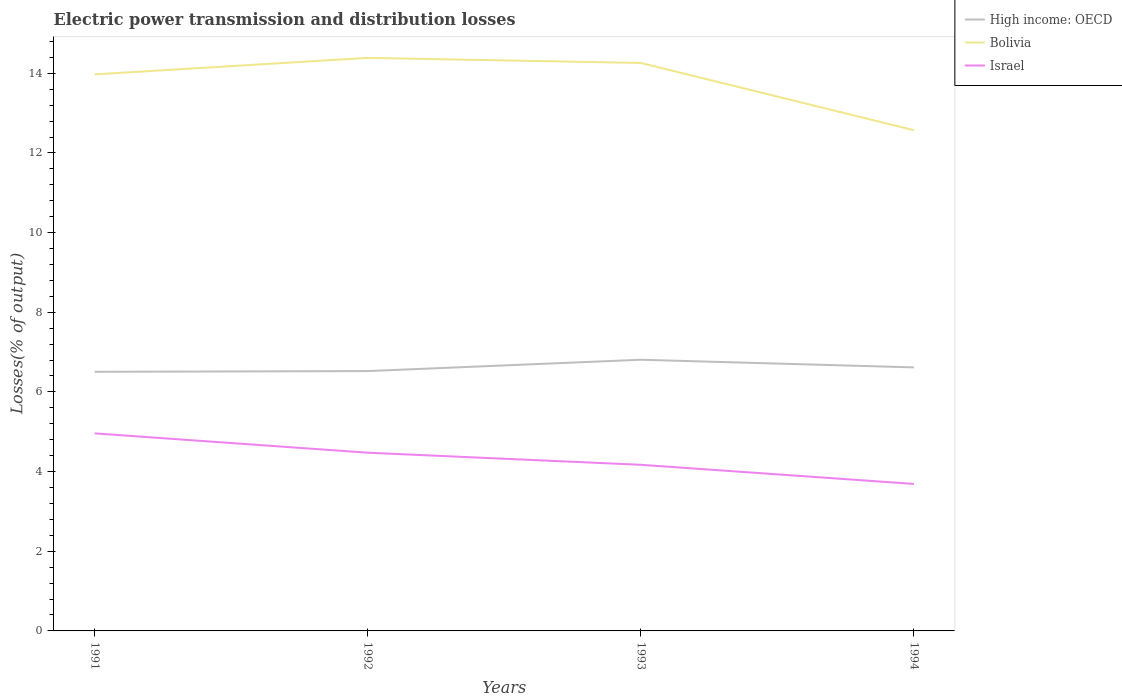Is the number of lines equal to the number of legend labels?
Make the answer very short. Yes. Across all years, what is the maximum electric power transmission and distribution losses in Bolivia?
Offer a very short reply. 12.57. In which year was the electric power transmission and distribution losses in Bolivia maximum?
Your response must be concise. 1994. What is the total electric power transmission and distribution losses in High income: OECD in the graph?
Offer a very short reply. -0.28. What is the difference between the highest and the second highest electric power transmission and distribution losses in Bolivia?
Your response must be concise. 1.82. What is the difference between the highest and the lowest electric power transmission and distribution losses in Israel?
Offer a very short reply. 2. Is the electric power transmission and distribution losses in High income: OECD strictly greater than the electric power transmission and distribution losses in Bolivia over the years?
Make the answer very short. Yes. How many lines are there?
Your answer should be very brief. 3. What is the difference between two consecutive major ticks on the Y-axis?
Your answer should be very brief. 2. Does the graph contain any zero values?
Provide a short and direct response. No. Does the graph contain grids?
Give a very brief answer. No. What is the title of the graph?
Your answer should be compact. Electric power transmission and distribution losses. What is the label or title of the Y-axis?
Offer a very short reply. Losses(% of output). What is the Losses(% of output) of High income: OECD in 1991?
Give a very brief answer. 6.51. What is the Losses(% of output) in Bolivia in 1991?
Provide a succinct answer. 13.97. What is the Losses(% of output) of Israel in 1991?
Give a very brief answer. 4.96. What is the Losses(% of output) of High income: OECD in 1992?
Ensure brevity in your answer.  6.52. What is the Losses(% of output) of Bolivia in 1992?
Provide a succinct answer. 14.39. What is the Losses(% of output) in Israel in 1992?
Give a very brief answer. 4.47. What is the Losses(% of output) in High income: OECD in 1993?
Your answer should be very brief. 6.81. What is the Losses(% of output) in Bolivia in 1993?
Ensure brevity in your answer.  14.26. What is the Losses(% of output) in Israel in 1993?
Offer a terse response. 4.17. What is the Losses(% of output) in High income: OECD in 1994?
Your answer should be compact. 6.62. What is the Losses(% of output) of Bolivia in 1994?
Give a very brief answer. 12.57. What is the Losses(% of output) of Israel in 1994?
Keep it short and to the point. 3.69. Across all years, what is the maximum Losses(% of output) in High income: OECD?
Give a very brief answer. 6.81. Across all years, what is the maximum Losses(% of output) in Bolivia?
Offer a terse response. 14.39. Across all years, what is the maximum Losses(% of output) in Israel?
Give a very brief answer. 4.96. Across all years, what is the minimum Losses(% of output) of High income: OECD?
Ensure brevity in your answer.  6.51. Across all years, what is the minimum Losses(% of output) in Bolivia?
Offer a very short reply. 12.57. Across all years, what is the minimum Losses(% of output) in Israel?
Ensure brevity in your answer.  3.69. What is the total Losses(% of output) in High income: OECD in the graph?
Offer a terse response. 26.45. What is the total Losses(% of output) of Bolivia in the graph?
Make the answer very short. 55.19. What is the total Losses(% of output) in Israel in the graph?
Provide a succinct answer. 17.3. What is the difference between the Losses(% of output) of High income: OECD in 1991 and that in 1992?
Your response must be concise. -0.02. What is the difference between the Losses(% of output) of Bolivia in 1991 and that in 1992?
Keep it short and to the point. -0.41. What is the difference between the Losses(% of output) in Israel in 1991 and that in 1992?
Your response must be concise. 0.49. What is the difference between the Losses(% of output) in High income: OECD in 1991 and that in 1993?
Give a very brief answer. -0.3. What is the difference between the Losses(% of output) in Bolivia in 1991 and that in 1993?
Ensure brevity in your answer.  -0.29. What is the difference between the Losses(% of output) of Israel in 1991 and that in 1993?
Offer a very short reply. 0.79. What is the difference between the Losses(% of output) in High income: OECD in 1991 and that in 1994?
Keep it short and to the point. -0.11. What is the difference between the Losses(% of output) of Bolivia in 1991 and that in 1994?
Your response must be concise. 1.4. What is the difference between the Losses(% of output) in Israel in 1991 and that in 1994?
Give a very brief answer. 1.27. What is the difference between the Losses(% of output) in High income: OECD in 1992 and that in 1993?
Your answer should be compact. -0.28. What is the difference between the Losses(% of output) of Bolivia in 1992 and that in 1993?
Offer a terse response. 0.13. What is the difference between the Losses(% of output) in Israel in 1992 and that in 1993?
Your answer should be compact. 0.3. What is the difference between the Losses(% of output) of High income: OECD in 1992 and that in 1994?
Provide a short and direct response. -0.09. What is the difference between the Losses(% of output) of Bolivia in 1992 and that in 1994?
Make the answer very short. 1.82. What is the difference between the Losses(% of output) of Israel in 1992 and that in 1994?
Provide a succinct answer. 0.78. What is the difference between the Losses(% of output) in High income: OECD in 1993 and that in 1994?
Make the answer very short. 0.19. What is the difference between the Losses(% of output) of Bolivia in 1993 and that in 1994?
Offer a very short reply. 1.69. What is the difference between the Losses(% of output) in Israel in 1993 and that in 1994?
Your response must be concise. 0.48. What is the difference between the Losses(% of output) in High income: OECD in 1991 and the Losses(% of output) in Bolivia in 1992?
Your answer should be very brief. -7.88. What is the difference between the Losses(% of output) of High income: OECD in 1991 and the Losses(% of output) of Israel in 1992?
Provide a succinct answer. 2.03. What is the difference between the Losses(% of output) in Bolivia in 1991 and the Losses(% of output) in Israel in 1992?
Your answer should be very brief. 9.5. What is the difference between the Losses(% of output) of High income: OECD in 1991 and the Losses(% of output) of Bolivia in 1993?
Your response must be concise. -7.75. What is the difference between the Losses(% of output) in High income: OECD in 1991 and the Losses(% of output) in Israel in 1993?
Provide a short and direct response. 2.33. What is the difference between the Losses(% of output) in Bolivia in 1991 and the Losses(% of output) in Israel in 1993?
Provide a short and direct response. 9.8. What is the difference between the Losses(% of output) of High income: OECD in 1991 and the Losses(% of output) of Bolivia in 1994?
Provide a short and direct response. -6.07. What is the difference between the Losses(% of output) of High income: OECD in 1991 and the Losses(% of output) of Israel in 1994?
Give a very brief answer. 2.81. What is the difference between the Losses(% of output) of Bolivia in 1991 and the Losses(% of output) of Israel in 1994?
Make the answer very short. 10.28. What is the difference between the Losses(% of output) of High income: OECD in 1992 and the Losses(% of output) of Bolivia in 1993?
Give a very brief answer. -7.74. What is the difference between the Losses(% of output) in High income: OECD in 1992 and the Losses(% of output) in Israel in 1993?
Make the answer very short. 2.35. What is the difference between the Losses(% of output) in Bolivia in 1992 and the Losses(% of output) in Israel in 1993?
Offer a terse response. 10.22. What is the difference between the Losses(% of output) in High income: OECD in 1992 and the Losses(% of output) in Bolivia in 1994?
Provide a succinct answer. -6.05. What is the difference between the Losses(% of output) of High income: OECD in 1992 and the Losses(% of output) of Israel in 1994?
Your response must be concise. 2.83. What is the difference between the Losses(% of output) of Bolivia in 1992 and the Losses(% of output) of Israel in 1994?
Offer a very short reply. 10.7. What is the difference between the Losses(% of output) in High income: OECD in 1993 and the Losses(% of output) in Bolivia in 1994?
Your response must be concise. -5.76. What is the difference between the Losses(% of output) in High income: OECD in 1993 and the Losses(% of output) in Israel in 1994?
Make the answer very short. 3.12. What is the difference between the Losses(% of output) of Bolivia in 1993 and the Losses(% of output) of Israel in 1994?
Provide a succinct answer. 10.57. What is the average Losses(% of output) of High income: OECD per year?
Your answer should be compact. 6.61. What is the average Losses(% of output) of Bolivia per year?
Your response must be concise. 13.8. What is the average Losses(% of output) of Israel per year?
Offer a very short reply. 4.32. In the year 1991, what is the difference between the Losses(% of output) in High income: OECD and Losses(% of output) in Bolivia?
Provide a succinct answer. -7.47. In the year 1991, what is the difference between the Losses(% of output) in High income: OECD and Losses(% of output) in Israel?
Make the answer very short. 1.55. In the year 1991, what is the difference between the Losses(% of output) in Bolivia and Losses(% of output) in Israel?
Your response must be concise. 9.01. In the year 1992, what is the difference between the Losses(% of output) of High income: OECD and Losses(% of output) of Bolivia?
Offer a very short reply. -7.86. In the year 1992, what is the difference between the Losses(% of output) in High income: OECD and Losses(% of output) in Israel?
Ensure brevity in your answer.  2.05. In the year 1992, what is the difference between the Losses(% of output) in Bolivia and Losses(% of output) in Israel?
Keep it short and to the point. 9.91. In the year 1993, what is the difference between the Losses(% of output) of High income: OECD and Losses(% of output) of Bolivia?
Your response must be concise. -7.45. In the year 1993, what is the difference between the Losses(% of output) of High income: OECD and Losses(% of output) of Israel?
Your response must be concise. 2.64. In the year 1993, what is the difference between the Losses(% of output) of Bolivia and Losses(% of output) of Israel?
Your answer should be very brief. 10.09. In the year 1994, what is the difference between the Losses(% of output) in High income: OECD and Losses(% of output) in Bolivia?
Offer a terse response. -5.95. In the year 1994, what is the difference between the Losses(% of output) of High income: OECD and Losses(% of output) of Israel?
Make the answer very short. 2.93. In the year 1994, what is the difference between the Losses(% of output) in Bolivia and Losses(% of output) in Israel?
Your answer should be very brief. 8.88. What is the ratio of the Losses(% of output) in High income: OECD in 1991 to that in 1992?
Keep it short and to the point. 1. What is the ratio of the Losses(% of output) of Bolivia in 1991 to that in 1992?
Offer a terse response. 0.97. What is the ratio of the Losses(% of output) in Israel in 1991 to that in 1992?
Your answer should be very brief. 1.11. What is the ratio of the Losses(% of output) of High income: OECD in 1991 to that in 1993?
Provide a short and direct response. 0.96. What is the ratio of the Losses(% of output) in Bolivia in 1991 to that in 1993?
Keep it short and to the point. 0.98. What is the ratio of the Losses(% of output) in Israel in 1991 to that in 1993?
Ensure brevity in your answer.  1.19. What is the ratio of the Losses(% of output) in High income: OECD in 1991 to that in 1994?
Offer a very short reply. 0.98. What is the ratio of the Losses(% of output) in Bolivia in 1991 to that in 1994?
Your response must be concise. 1.11. What is the ratio of the Losses(% of output) of Israel in 1991 to that in 1994?
Ensure brevity in your answer.  1.34. What is the ratio of the Losses(% of output) of High income: OECD in 1992 to that in 1993?
Your response must be concise. 0.96. What is the ratio of the Losses(% of output) in Israel in 1992 to that in 1993?
Keep it short and to the point. 1.07. What is the ratio of the Losses(% of output) in High income: OECD in 1992 to that in 1994?
Your answer should be compact. 0.99. What is the ratio of the Losses(% of output) in Bolivia in 1992 to that in 1994?
Keep it short and to the point. 1.14. What is the ratio of the Losses(% of output) in Israel in 1992 to that in 1994?
Provide a short and direct response. 1.21. What is the ratio of the Losses(% of output) of Bolivia in 1993 to that in 1994?
Offer a terse response. 1.13. What is the ratio of the Losses(% of output) in Israel in 1993 to that in 1994?
Your response must be concise. 1.13. What is the difference between the highest and the second highest Losses(% of output) of High income: OECD?
Offer a very short reply. 0.19. What is the difference between the highest and the second highest Losses(% of output) of Bolivia?
Your answer should be very brief. 0.13. What is the difference between the highest and the second highest Losses(% of output) of Israel?
Provide a succinct answer. 0.49. What is the difference between the highest and the lowest Losses(% of output) in High income: OECD?
Give a very brief answer. 0.3. What is the difference between the highest and the lowest Losses(% of output) in Bolivia?
Offer a terse response. 1.82. What is the difference between the highest and the lowest Losses(% of output) of Israel?
Ensure brevity in your answer.  1.27. 